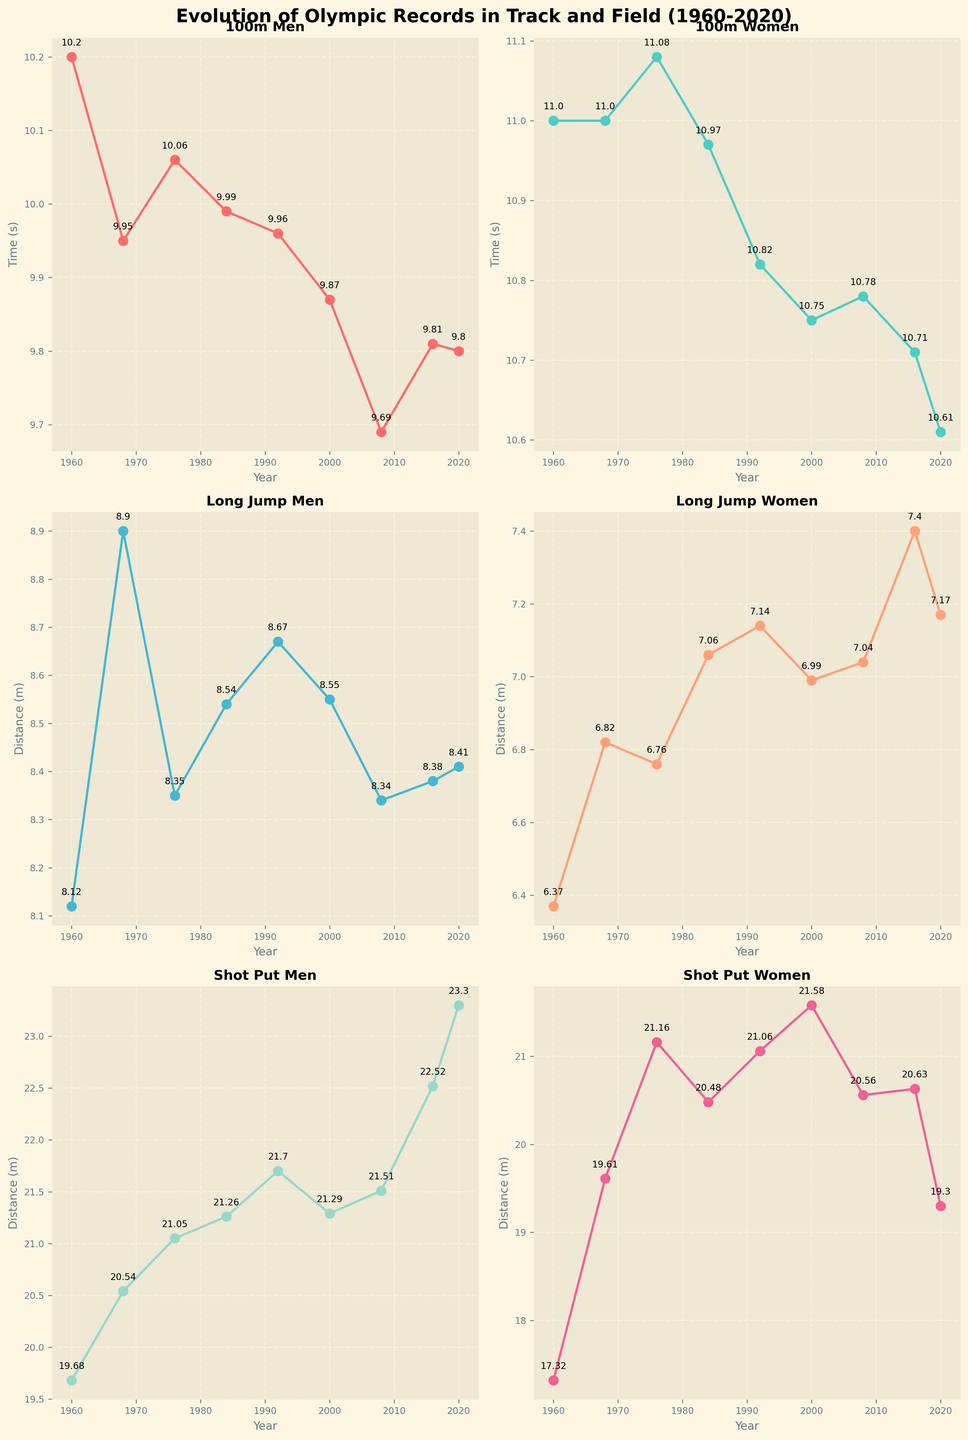What is the title of the figure? The title is found at the top of the figure and summarizes the main topic being visualized. Here, it states "Evolution of Olympic Records in Track and Field (1960-2020)."
Answer: Evolution of Olympic Records in Track and Field (1960-2020) How many subplots are there in the figure? The figure is divided into smaller plots for each event, and each event's plot is placed in its own subplot within the vertical arrangement. By counting the individual plots, we see there are six subplots.
Answer: Six Which event shows the most significant improvement in the men's category from 1960 to 2020? To determine the most significant improvement, look for the largest difference in the records over the years. The 100m Men's event improves from 10.2 seconds in 1960 to 9.80 seconds in 2020, a decrease of 0.4 seconds.
Answer: 100m Men What was the Olympic record for women's long jump in 1984? To find this, locate the subplot for the Long Jump Women and check the data point for the year 1984. The record is marked at 7.06 meters.
Answer: 7.06 meters Between which years did the women's shot put event see its highest recorded improvement? First, identify the subplot for Shot Put Women. Next, compare the records over the years and find the period with the largest increase. From 1968 to 1976, the record improved significantly from 19.61 meters to 21.16 meters, a difference of 1.55 meters.
Answer: 1968 to 1976 How does the 2020 Olympic record for the men's 100m compare to the 2008 record? Locate the 100m Men subplot and find the records for 2020 and 2008. In 2020, the record is 9.80 seconds, and in 2008, it's 9.69 seconds. Thus, the 2020 record is slower by 0.11 seconds.
Answer: 0.11 seconds slower What is the average improvement in the men's shot put event between 1960 and 2020, given 5 records to average over? List the records: 19.68, 20.54, 21.05, 21.26, 21.70, 21.29, 21.51, 22.52, and 23.30. Calculate the differences year over year, sum them, and divide by the number of intervals (8 intervals).
Answer: Approximately 0.47 meters per interval In which year did the women's 100m event see its first record drop below 11 seconds? By observing the 100m Women subplot, find the first year where the recording is below 11 seconds. This occurs in 1984 with a record of 10.97 seconds.
Answer: 1984 Comparing the long jump events, which gender had a better record in 2000, and what were the distances? Check the Long Jump Men and Long Jump Women subplots for the year 2000. Men had a record of 8.55 meters, while women had 6.99 meters. Hence men had a better record.
Answer: Men, 8.55 meters 